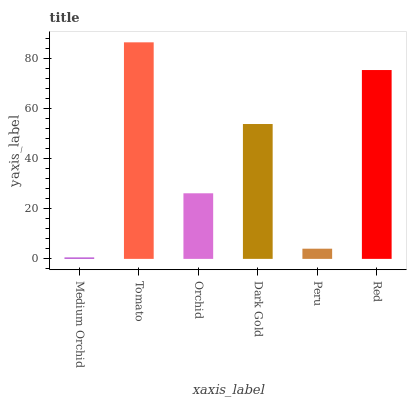Is Medium Orchid the minimum?
Answer yes or no. Yes. Is Tomato the maximum?
Answer yes or no. Yes. Is Orchid the minimum?
Answer yes or no. No. Is Orchid the maximum?
Answer yes or no. No. Is Tomato greater than Orchid?
Answer yes or no. Yes. Is Orchid less than Tomato?
Answer yes or no. Yes. Is Orchid greater than Tomato?
Answer yes or no. No. Is Tomato less than Orchid?
Answer yes or no. No. Is Dark Gold the high median?
Answer yes or no. Yes. Is Orchid the low median?
Answer yes or no. Yes. Is Peru the high median?
Answer yes or no. No. Is Peru the low median?
Answer yes or no. No. 